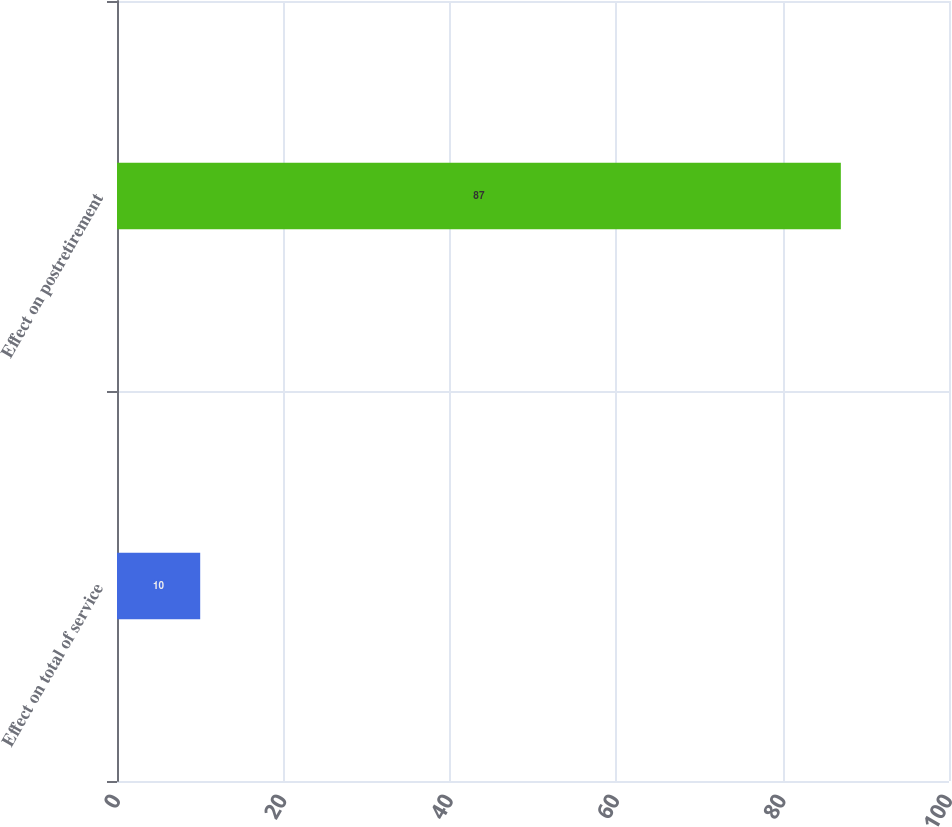<chart> <loc_0><loc_0><loc_500><loc_500><bar_chart><fcel>Effect on total of service<fcel>Effect on postretirement<nl><fcel>10<fcel>87<nl></chart> 